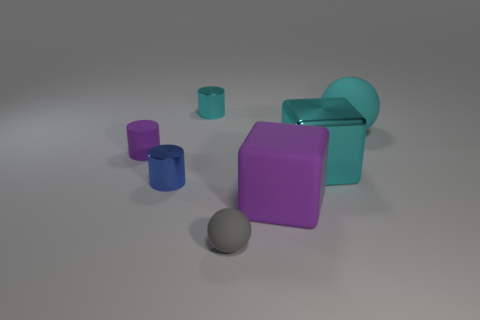Is the number of blue metallic objects behind the cyan cube less than the number of blue objects?
Your answer should be compact. Yes. Is there anything else that is the same size as the rubber block?
Keep it short and to the point. Yes. What is the size of the metallic cylinder that is in front of the tiny cylinder on the right side of the small blue metal cylinder?
Offer a very short reply. Small. Is there any other thing that is the same shape as the small cyan thing?
Keep it short and to the point. Yes. Is the number of big rubber things less than the number of large metal objects?
Provide a succinct answer. No. There is a small cylinder that is behind the small blue metallic cylinder and in front of the cyan shiny cylinder; what material is it made of?
Ensure brevity in your answer.  Rubber. Are there any big rubber objects behind the large rubber thing that is in front of the cyan rubber thing?
Provide a succinct answer. Yes. How many things are red cubes or large purple blocks?
Provide a short and direct response. 1. What is the shape of the object that is on the right side of the big purple rubber block and behind the big cyan metallic cube?
Give a very brief answer. Sphere. Is the material of the object in front of the purple cube the same as the large cyan block?
Your response must be concise. No. 